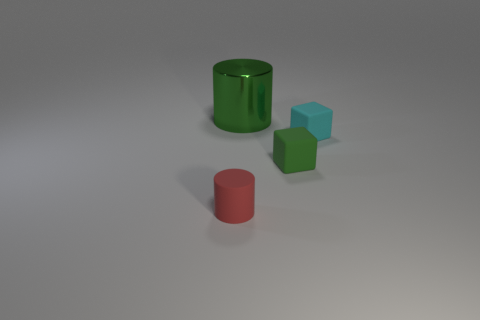Subtract 1 blocks. How many blocks are left? 1 Subtract all cyan cubes. Subtract all yellow cylinders. How many cubes are left? 1 Subtract all purple blocks. How many green cylinders are left? 1 Subtract all blue metal blocks. Subtract all red things. How many objects are left? 3 Add 2 large cylinders. How many large cylinders are left? 3 Add 4 big green cylinders. How many big green cylinders exist? 5 Add 3 small objects. How many objects exist? 7 Subtract 0 purple blocks. How many objects are left? 4 